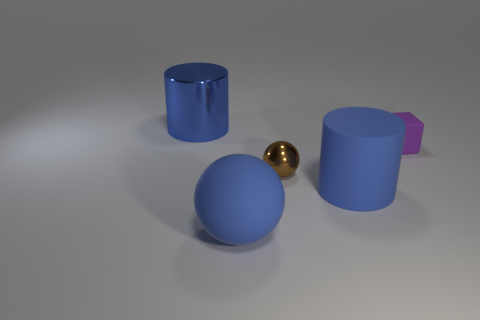There is a small object on the left side of the tiny purple rubber block; what is its shape?
Ensure brevity in your answer.  Sphere. What is the shape of the blue metallic thing that is the same size as the matte ball?
Provide a short and direct response. Cylinder. Are there any large rubber things of the same shape as the tiny brown object?
Provide a short and direct response. Yes. There is a rubber thing that is in front of the matte cylinder; does it have the same shape as the big rubber thing that is to the right of the tiny brown metallic thing?
Your response must be concise. No. There is a brown object that is the same size as the purple thing; what is its material?
Provide a succinct answer. Metal. What number of other objects are the same material as the small sphere?
Make the answer very short. 1. The big object that is behind the big cylinder that is in front of the purple matte cube is what shape?
Offer a very short reply. Cylinder. How many objects are big red things or objects on the right side of the rubber ball?
Make the answer very short. 3. How many other things are there of the same color as the large shiny cylinder?
Your response must be concise. 2. What number of gray things are big things or matte balls?
Ensure brevity in your answer.  0. 